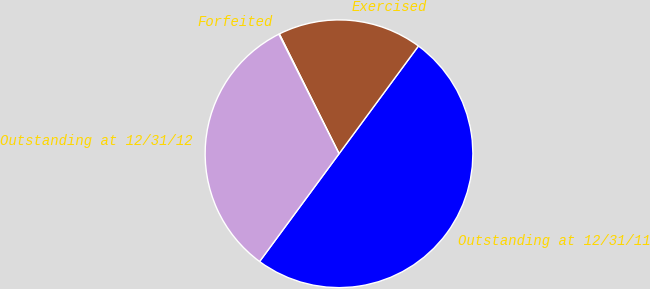<chart> <loc_0><loc_0><loc_500><loc_500><pie_chart><fcel>Outstanding at 12/31/11<fcel>Exercised<fcel>Forfeited<fcel>Outstanding at 12/31/12<nl><fcel>50.0%<fcel>17.46%<fcel>0.07%<fcel>32.47%<nl></chart> 